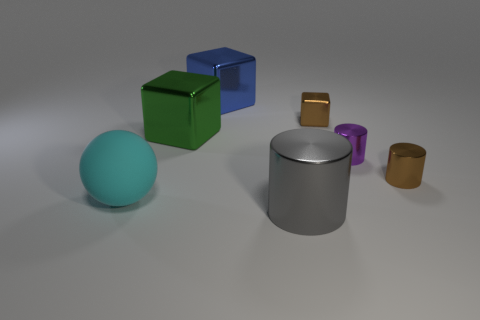How many small things are both in front of the tiny brown block and on the left side of the tiny purple cylinder?
Ensure brevity in your answer.  0. The large cylinder is what color?
Keep it short and to the point. Gray. There is a brown object that is the same shape as the small purple metal object; what material is it?
Your answer should be compact. Metal. Is there anything else that is the same material as the gray cylinder?
Offer a very short reply. Yes. Is the large cylinder the same color as the matte thing?
Your response must be concise. No. The brown object to the right of the small metallic object behind the large green metal object is what shape?
Ensure brevity in your answer.  Cylinder. What shape is the big blue thing that is the same material as the large green object?
Provide a short and direct response. Cube. How many other things are the same shape as the big gray thing?
Your response must be concise. 2. Do the brown thing that is behind the purple metallic cylinder and the large rubber object have the same size?
Provide a short and direct response. No. Is the number of big shiny cylinders that are behind the small brown metallic block greater than the number of large gray metal things?
Ensure brevity in your answer.  No. 